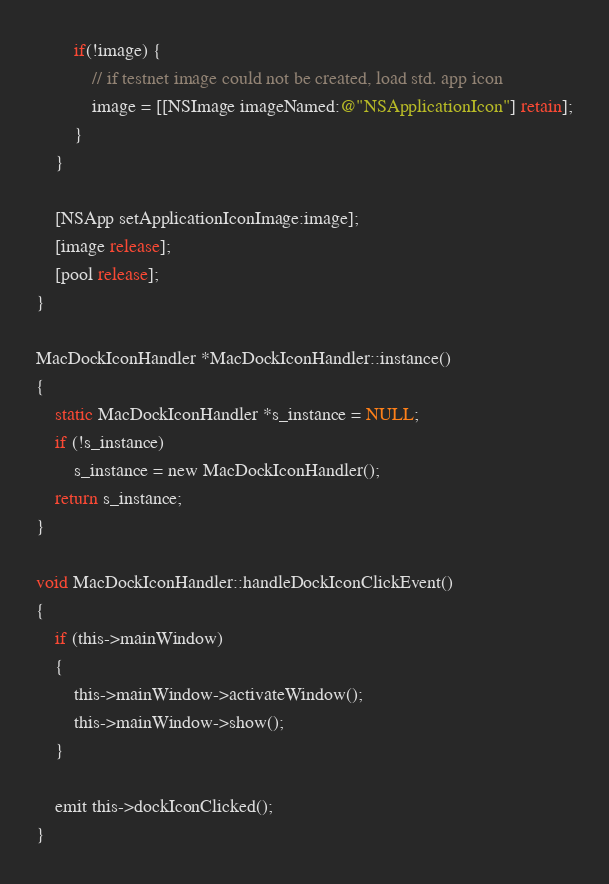<code> <loc_0><loc_0><loc_500><loc_500><_ObjectiveC_>        if(!image) {
            // if testnet image could not be created, load std. app icon
            image = [[NSImage imageNamed:@"NSApplicationIcon"] retain];
        }
    }

    [NSApp setApplicationIconImage:image];
    [image release];
    [pool release];
}

MacDockIconHandler *MacDockIconHandler::instance()
{
    static MacDockIconHandler *s_instance = NULL;
    if (!s_instance)
        s_instance = new MacDockIconHandler();
    return s_instance;
}

void MacDockIconHandler::handleDockIconClickEvent()
{
    if (this->mainWindow)
    {
        this->mainWindow->activateWindow();
        this->mainWindow->show();
    }

    emit this->dockIconClicked();
}
</code> 